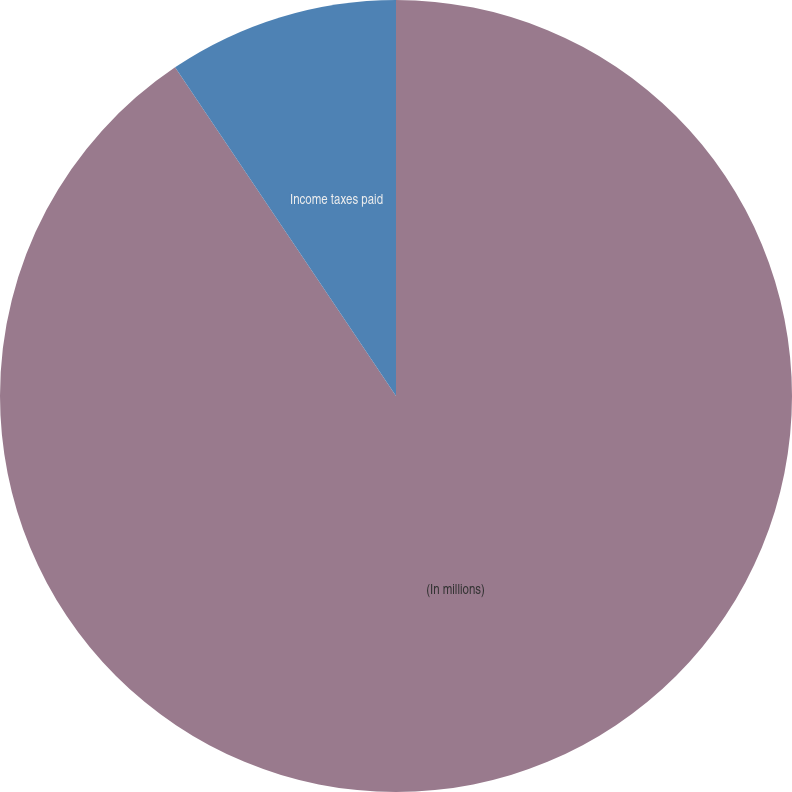Convert chart to OTSL. <chart><loc_0><loc_0><loc_500><loc_500><pie_chart><fcel>(In millions)<fcel>Income taxes paid<nl><fcel>90.58%<fcel>9.42%<nl></chart> 